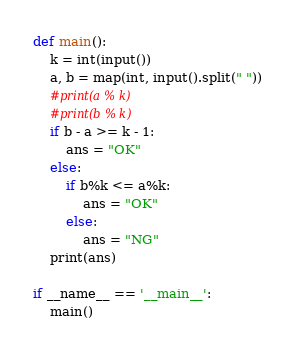Convert code to text. <code><loc_0><loc_0><loc_500><loc_500><_Python_>def main():
    k = int(input())
    a, b = map(int, input().split(" "))
    #print(a % k)
    #print(b % k)
    if b - a >= k - 1:
        ans = "OK"
    else:
        if b%k <= a%k:
            ans = "OK"
        else:
            ans = "NG"
    print(ans)

if __name__ == '__main__':
    main()
</code> 